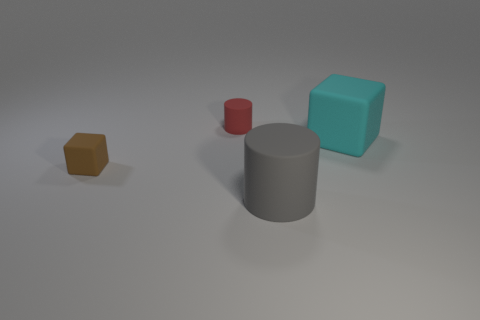What is the shape of the brown thing that is made of the same material as the tiny red cylinder?
Provide a short and direct response. Cube. Is the tiny rubber cube the same color as the tiny rubber cylinder?
Ensure brevity in your answer.  No. Is the material of the large object behind the small block the same as the cube left of the big gray cylinder?
Keep it short and to the point. Yes. What number of objects are either tiny yellow blocks or cylinders that are behind the large cyan cube?
Give a very brief answer. 1. Is there anything else that is made of the same material as the tiny block?
Your answer should be very brief. Yes. What is the material of the cyan cube?
Make the answer very short. Rubber. Do the brown object and the tiny cylinder have the same material?
Your answer should be very brief. Yes. What number of matte things are big gray cylinders or large cyan cubes?
Your response must be concise. 2. There is a big object that is behind the small brown cube; what shape is it?
Provide a short and direct response. Cube. There is a cylinder that is the same material as the red thing; what size is it?
Keep it short and to the point. Large. 